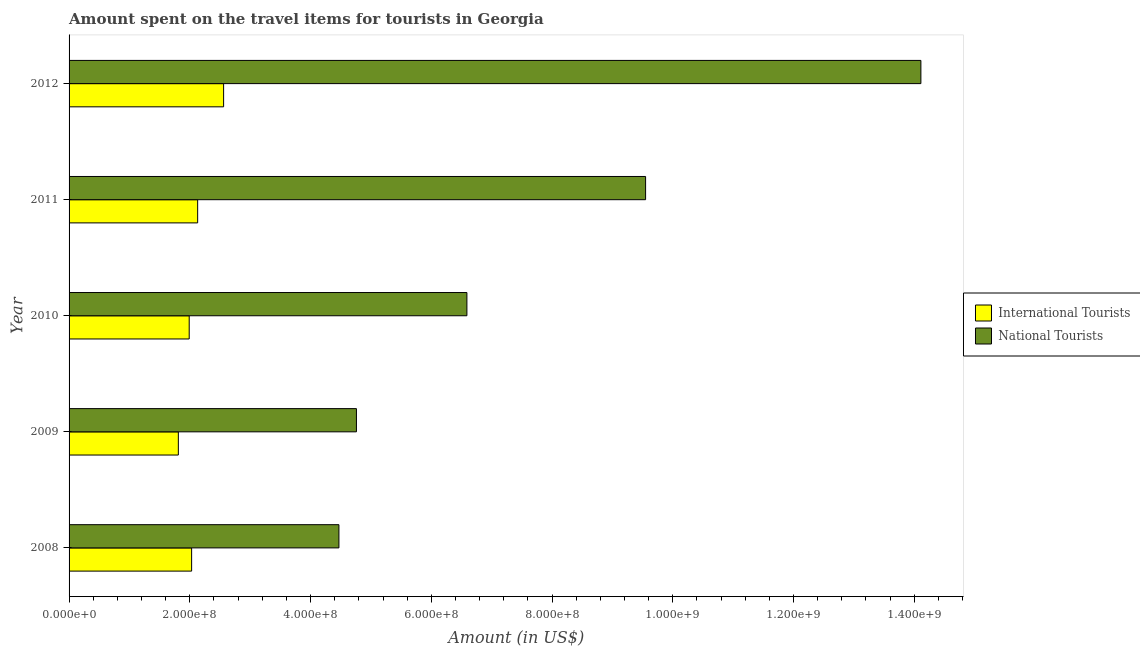How many different coloured bars are there?
Offer a very short reply. 2. How many groups of bars are there?
Your answer should be very brief. 5. How many bars are there on the 1st tick from the top?
Provide a succinct answer. 2. How many bars are there on the 4th tick from the bottom?
Ensure brevity in your answer.  2. In how many cases, is the number of bars for a given year not equal to the number of legend labels?
Make the answer very short. 0. What is the amount spent on travel items of international tourists in 2009?
Keep it short and to the point. 1.81e+08. Across all years, what is the maximum amount spent on travel items of national tourists?
Provide a short and direct response. 1.41e+09. Across all years, what is the minimum amount spent on travel items of national tourists?
Provide a short and direct response. 4.47e+08. In which year was the amount spent on travel items of international tourists maximum?
Your response must be concise. 2012. What is the total amount spent on travel items of national tourists in the graph?
Ensure brevity in your answer.  3.95e+09. What is the difference between the amount spent on travel items of national tourists in 2009 and that in 2012?
Provide a succinct answer. -9.35e+08. What is the difference between the amount spent on travel items of international tourists in 2012 and the amount spent on travel items of national tourists in 2009?
Keep it short and to the point. -2.20e+08. What is the average amount spent on travel items of national tourists per year?
Offer a very short reply. 7.90e+08. In the year 2009, what is the difference between the amount spent on travel items of national tourists and amount spent on travel items of international tourists?
Offer a very short reply. 2.95e+08. What is the ratio of the amount spent on travel items of national tourists in 2009 to that in 2010?
Ensure brevity in your answer.  0.72. Is the amount spent on travel items of international tourists in 2008 less than that in 2009?
Your answer should be very brief. No. What is the difference between the highest and the second highest amount spent on travel items of international tourists?
Your answer should be compact. 4.30e+07. What is the difference between the highest and the lowest amount spent on travel items of international tourists?
Your answer should be very brief. 7.50e+07. What does the 2nd bar from the top in 2011 represents?
Make the answer very short. International Tourists. What does the 1st bar from the bottom in 2012 represents?
Provide a succinct answer. International Tourists. Are all the bars in the graph horizontal?
Provide a short and direct response. Yes. What is the difference between two consecutive major ticks on the X-axis?
Give a very brief answer. 2.00e+08. Are the values on the major ticks of X-axis written in scientific E-notation?
Ensure brevity in your answer.  Yes. What is the title of the graph?
Your answer should be very brief. Amount spent on the travel items for tourists in Georgia. Does "% of gross capital formation" appear as one of the legend labels in the graph?
Offer a terse response. No. What is the label or title of the X-axis?
Keep it short and to the point. Amount (in US$). What is the label or title of the Y-axis?
Provide a succinct answer. Year. What is the Amount (in US$) of International Tourists in 2008?
Your answer should be compact. 2.03e+08. What is the Amount (in US$) of National Tourists in 2008?
Make the answer very short. 4.47e+08. What is the Amount (in US$) in International Tourists in 2009?
Provide a succinct answer. 1.81e+08. What is the Amount (in US$) in National Tourists in 2009?
Provide a short and direct response. 4.76e+08. What is the Amount (in US$) of International Tourists in 2010?
Offer a terse response. 1.99e+08. What is the Amount (in US$) of National Tourists in 2010?
Give a very brief answer. 6.59e+08. What is the Amount (in US$) of International Tourists in 2011?
Your answer should be compact. 2.13e+08. What is the Amount (in US$) of National Tourists in 2011?
Give a very brief answer. 9.55e+08. What is the Amount (in US$) of International Tourists in 2012?
Your answer should be very brief. 2.56e+08. What is the Amount (in US$) of National Tourists in 2012?
Your answer should be very brief. 1.41e+09. Across all years, what is the maximum Amount (in US$) in International Tourists?
Provide a short and direct response. 2.56e+08. Across all years, what is the maximum Amount (in US$) of National Tourists?
Provide a short and direct response. 1.41e+09. Across all years, what is the minimum Amount (in US$) of International Tourists?
Your answer should be very brief. 1.81e+08. Across all years, what is the minimum Amount (in US$) of National Tourists?
Make the answer very short. 4.47e+08. What is the total Amount (in US$) of International Tourists in the graph?
Provide a succinct answer. 1.05e+09. What is the total Amount (in US$) in National Tourists in the graph?
Make the answer very short. 3.95e+09. What is the difference between the Amount (in US$) in International Tourists in 2008 and that in 2009?
Your answer should be compact. 2.20e+07. What is the difference between the Amount (in US$) of National Tourists in 2008 and that in 2009?
Your answer should be very brief. -2.90e+07. What is the difference between the Amount (in US$) in National Tourists in 2008 and that in 2010?
Ensure brevity in your answer.  -2.12e+08. What is the difference between the Amount (in US$) in International Tourists in 2008 and that in 2011?
Your answer should be compact. -1.00e+07. What is the difference between the Amount (in US$) in National Tourists in 2008 and that in 2011?
Your answer should be compact. -5.08e+08. What is the difference between the Amount (in US$) in International Tourists in 2008 and that in 2012?
Keep it short and to the point. -5.30e+07. What is the difference between the Amount (in US$) of National Tourists in 2008 and that in 2012?
Your response must be concise. -9.64e+08. What is the difference between the Amount (in US$) of International Tourists in 2009 and that in 2010?
Give a very brief answer. -1.80e+07. What is the difference between the Amount (in US$) in National Tourists in 2009 and that in 2010?
Offer a terse response. -1.83e+08. What is the difference between the Amount (in US$) in International Tourists in 2009 and that in 2011?
Your answer should be compact. -3.20e+07. What is the difference between the Amount (in US$) in National Tourists in 2009 and that in 2011?
Make the answer very short. -4.79e+08. What is the difference between the Amount (in US$) in International Tourists in 2009 and that in 2012?
Your response must be concise. -7.50e+07. What is the difference between the Amount (in US$) in National Tourists in 2009 and that in 2012?
Provide a succinct answer. -9.35e+08. What is the difference between the Amount (in US$) in International Tourists in 2010 and that in 2011?
Offer a very short reply. -1.40e+07. What is the difference between the Amount (in US$) in National Tourists in 2010 and that in 2011?
Make the answer very short. -2.96e+08. What is the difference between the Amount (in US$) of International Tourists in 2010 and that in 2012?
Keep it short and to the point. -5.70e+07. What is the difference between the Amount (in US$) of National Tourists in 2010 and that in 2012?
Offer a very short reply. -7.52e+08. What is the difference between the Amount (in US$) in International Tourists in 2011 and that in 2012?
Ensure brevity in your answer.  -4.30e+07. What is the difference between the Amount (in US$) in National Tourists in 2011 and that in 2012?
Provide a short and direct response. -4.56e+08. What is the difference between the Amount (in US$) of International Tourists in 2008 and the Amount (in US$) of National Tourists in 2009?
Your answer should be very brief. -2.73e+08. What is the difference between the Amount (in US$) of International Tourists in 2008 and the Amount (in US$) of National Tourists in 2010?
Make the answer very short. -4.56e+08. What is the difference between the Amount (in US$) in International Tourists in 2008 and the Amount (in US$) in National Tourists in 2011?
Keep it short and to the point. -7.52e+08. What is the difference between the Amount (in US$) in International Tourists in 2008 and the Amount (in US$) in National Tourists in 2012?
Offer a very short reply. -1.21e+09. What is the difference between the Amount (in US$) of International Tourists in 2009 and the Amount (in US$) of National Tourists in 2010?
Ensure brevity in your answer.  -4.78e+08. What is the difference between the Amount (in US$) of International Tourists in 2009 and the Amount (in US$) of National Tourists in 2011?
Offer a very short reply. -7.74e+08. What is the difference between the Amount (in US$) of International Tourists in 2009 and the Amount (in US$) of National Tourists in 2012?
Ensure brevity in your answer.  -1.23e+09. What is the difference between the Amount (in US$) of International Tourists in 2010 and the Amount (in US$) of National Tourists in 2011?
Offer a very short reply. -7.56e+08. What is the difference between the Amount (in US$) in International Tourists in 2010 and the Amount (in US$) in National Tourists in 2012?
Offer a very short reply. -1.21e+09. What is the difference between the Amount (in US$) in International Tourists in 2011 and the Amount (in US$) in National Tourists in 2012?
Your answer should be very brief. -1.20e+09. What is the average Amount (in US$) of International Tourists per year?
Your response must be concise. 2.10e+08. What is the average Amount (in US$) of National Tourists per year?
Keep it short and to the point. 7.90e+08. In the year 2008, what is the difference between the Amount (in US$) of International Tourists and Amount (in US$) of National Tourists?
Offer a terse response. -2.44e+08. In the year 2009, what is the difference between the Amount (in US$) in International Tourists and Amount (in US$) in National Tourists?
Make the answer very short. -2.95e+08. In the year 2010, what is the difference between the Amount (in US$) in International Tourists and Amount (in US$) in National Tourists?
Ensure brevity in your answer.  -4.60e+08. In the year 2011, what is the difference between the Amount (in US$) of International Tourists and Amount (in US$) of National Tourists?
Keep it short and to the point. -7.42e+08. In the year 2012, what is the difference between the Amount (in US$) of International Tourists and Amount (in US$) of National Tourists?
Your answer should be very brief. -1.16e+09. What is the ratio of the Amount (in US$) of International Tourists in 2008 to that in 2009?
Give a very brief answer. 1.12. What is the ratio of the Amount (in US$) in National Tourists in 2008 to that in 2009?
Offer a very short reply. 0.94. What is the ratio of the Amount (in US$) in International Tourists in 2008 to that in 2010?
Keep it short and to the point. 1.02. What is the ratio of the Amount (in US$) of National Tourists in 2008 to that in 2010?
Keep it short and to the point. 0.68. What is the ratio of the Amount (in US$) of International Tourists in 2008 to that in 2011?
Your answer should be compact. 0.95. What is the ratio of the Amount (in US$) of National Tourists in 2008 to that in 2011?
Keep it short and to the point. 0.47. What is the ratio of the Amount (in US$) of International Tourists in 2008 to that in 2012?
Keep it short and to the point. 0.79. What is the ratio of the Amount (in US$) in National Tourists in 2008 to that in 2012?
Offer a very short reply. 0.32. What is the ratio of the Amount (in US$) in International Tourists in 2009 to that in 2010?
Your answer should be very brief. 0.91. What is the ratio of the Amount (in US$) of National Tourists in 2009 to that in 2010?
Provide a short and direct response. 0.72. What is the ratio of the Amount (in US$) of International Tourists in 2009 to that in 2011?
Provide a short and direct response. 0.85. What is the ratio of the Amount (in US$) of National Tourists in 2009 to that in 2011?
Ensure brevity in your answer.  0.5. What is the ratio of the Amount (in US$) in International Tourists in 2009 to that in 2012?
Keep it short and to the point. 0.71. What is the ratio of the Amount (in US$) of National Tourists in 2009 to that in 2012?
Your answer should be compact. 0.34. What is the ratio of the Amount (in US$) in International Tourists in 2010 to that in 2011?
Your answer should be compact. 0.93. What is the ratio of the Amount (in US$) of National Tourists in 2010 to that in 2011?
Offer a terse response. 0.69. What is the ratio of the Amount (in US$) in International Tourists in 2010 to that in 2012?
Your answer should be compact. 0.78. What is the ratio of the Amount (in US$) of National Tourists in 2010 to that in 2012?
Keep it short and to the point. 0.47. What is the ratio of the Amount (in US$) in International Tourists in 2011 to that in 2012?
Provide a short and direct response. 0.83. What is the ratio of the Amount (in US$) of National Tourists in 2011 to that in 2012?
Offer a very short reply. 0.68. What is the difference between the highest and the second highest Amount (in US$) of International Tourists?
Your answer should be compact. 4.30e+07. What is the difference between the highest and the second highest Amount (in US$) of National Tourists?
Provide a succinct answer. 4.56e+08. What is the difference between the highest and the lowest Amount (in US$) of International Tourists?
Your answer should be very brief. 7.50e+07. What is the difference between the highest and the lowest Amount (in US$) in National Tourists?
Give a very brief answer. 9.64e+08. 